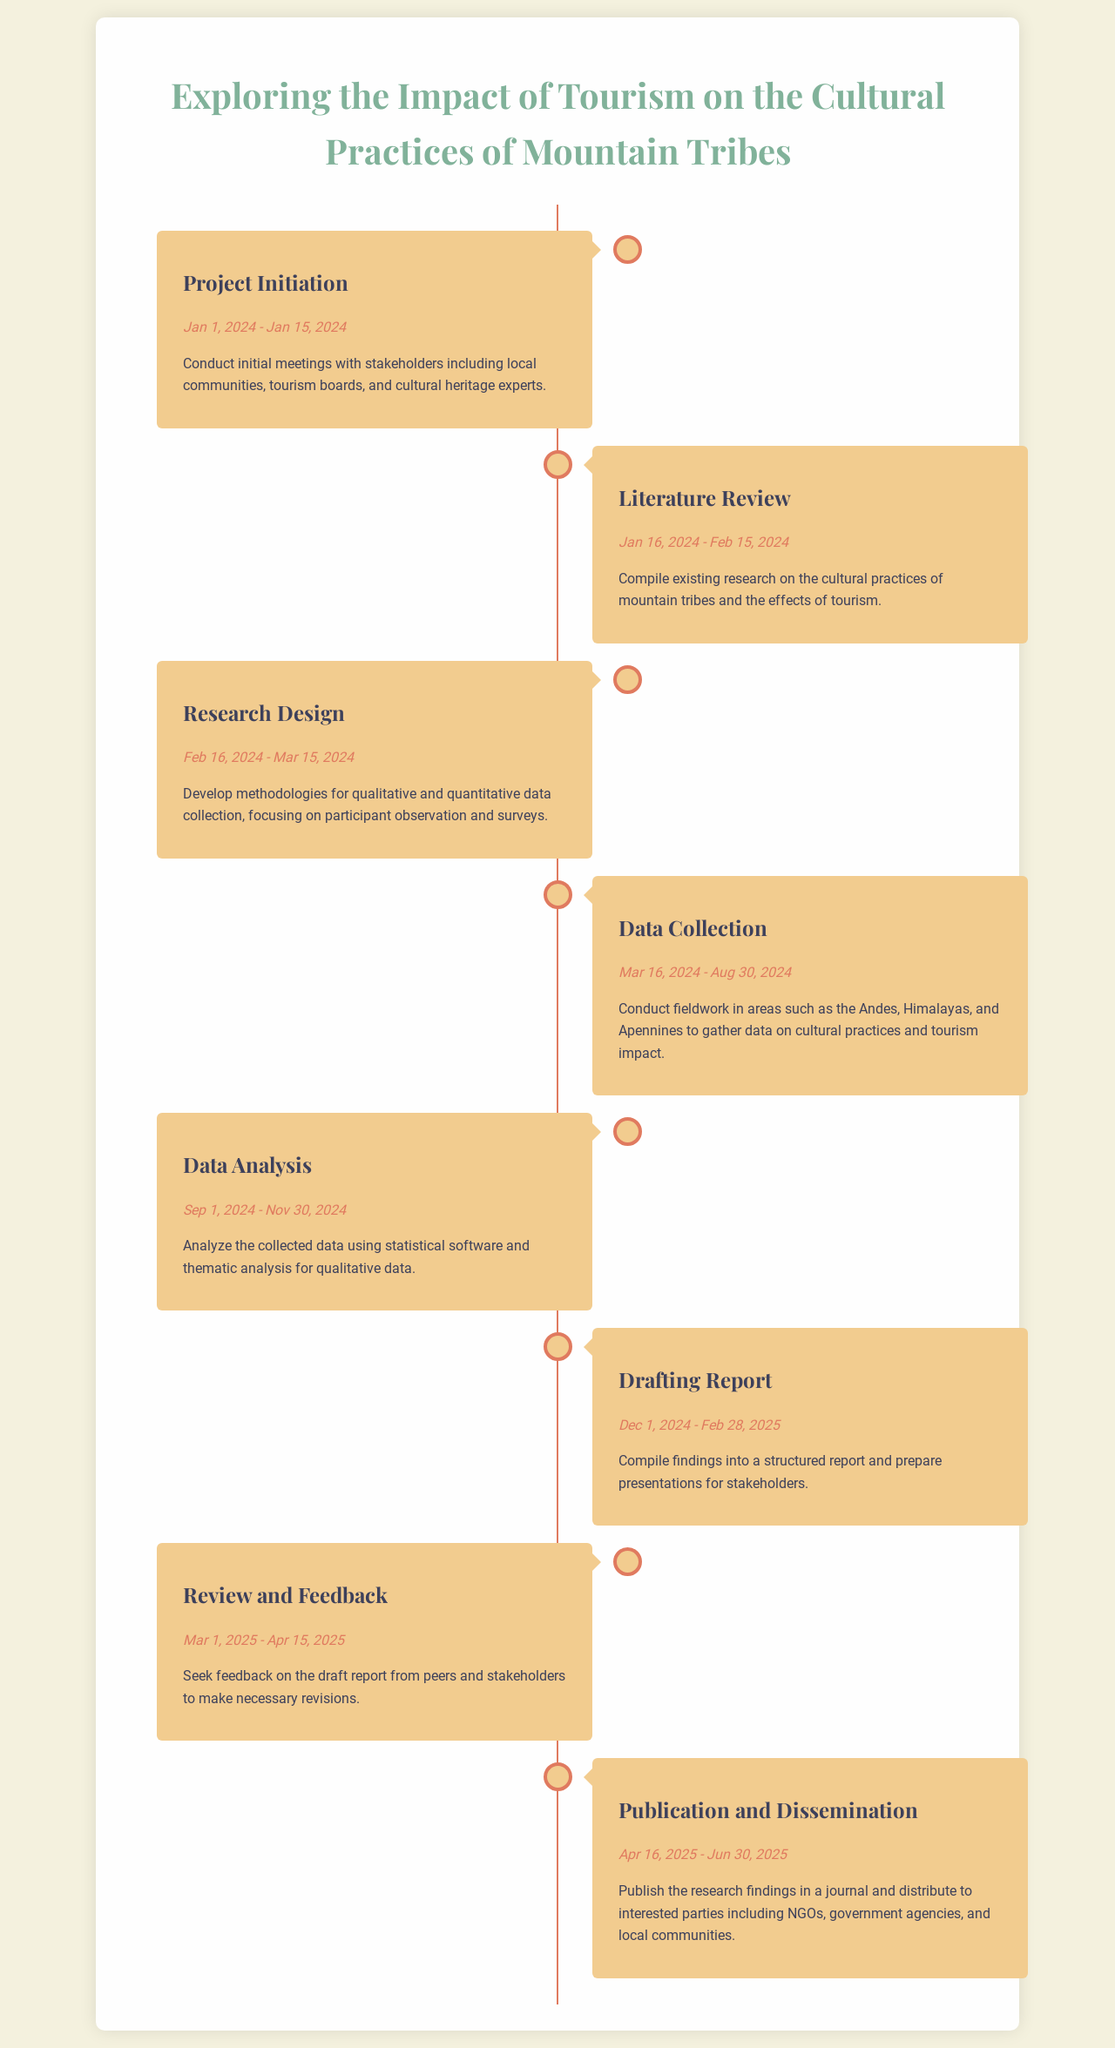What is the project initiation date? The project initiation date is specified in the timeline as the start and end date for this phase, which is from January 1, 2024, to January 15, 2024.
Answer: January 1, 2024 - January 15, 2024 What is the main focus of the literature review phase? The literature review phase focuses on compiling existing research related to the cultural practices of mountain tribes and the effects of tourism during the specified time period.
Answer: Compile existing research What are the two methodologies mentioned for data collection? The methodologies for data collection are outlined in the research design section, which emphasizes participant observation and surveys.
Answer: Participant observation and surveys During which phase is fieldwork conducted? The phase during which fieldwork is conducted involves gathering data in various regions, including the Andes, Himalayas, and Apennines, emphasizing the timeline period for this activity.
Answer: Data Collection What is the duration of the data analysis phase? The duration of the data analysis phase is indicated by its start and end dates, showing how long the analysis will take place.
Answer: September 1, 2024 - November 30, 2024 In which phase is feedback sought on the draft report? The specific phase in which feedback on the draft report is sought is mentioned in the schedule, detailing when this interaction with peers and stakeholders takes place.
Answer: Review and Feedback When will the research findings be published? The timeline specifically indicates the publication and dissemination of findings during this phase, showing the targeted timeframe for releasing the research results.
Answer: April 16, 2025 - June 30, 2025 What is the purpose of the drafting report phase? The drafting report phase serves the purpose of compiling the research findings into a structured report and preparing presentations for various stakeholders.
Answer: Compile findings into a structured report 